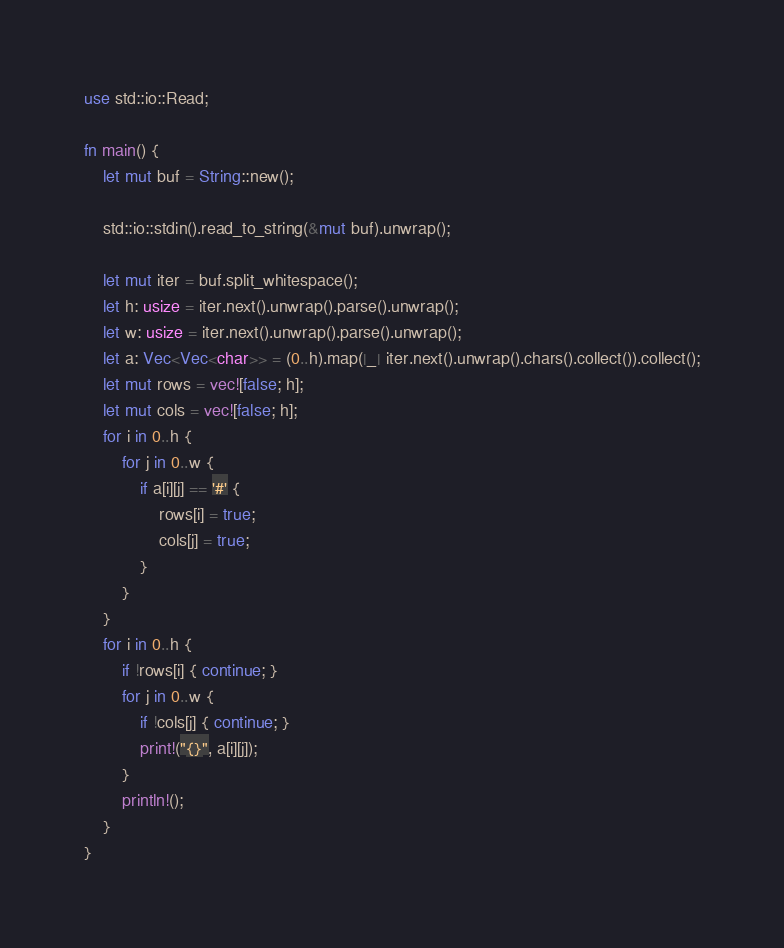Convert code to text. <code><loc_0><loc_0><loc_500><loc_500><_Rust_>use std::io::Read;

fn main() {
    let mut buf = String::new();

    std::io::stdin().read_to_string(&mut buf).unwrap();

    let mut iter = buf.split_whitespace();
    let h: usize = iter.next().unwrap().parse().unwrap();    
    let w: usize = iter.next().unwrap().parse().unwrap();    
    let a: Vec<Vec<char>> = (0..h).map(|_| iter.next().unwrap().chars().collect()).collect();
    let mut rows = vec![false; h];
    let mut cols = vec![false; h];
    for i in 0..h {
        for j in 0..w {
            if a[i][j] == '#' {
                rows[i] = true;
                cols[j] = true;
            }
        }
    }
    for i in 0..h {
        if !rows[i] { continue; }
        for j in 0..w {            
            if !cols[j] { continue; }
            print!("{}", a[i][j]);
        }
        println!();
    }
}

</code> 